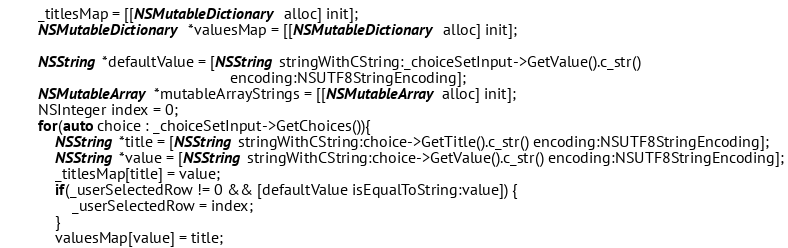<code> <loc_0><loc_0><loc_500><loc_500><_ObjectiveC_>        _titlesMap = [[NSMutableDictionary alloc] init];
        NSMutableDictionary *valuesMap = [[NSMutableDictionary alloc] init];

        NSString *defaultValue = [NSString stringWithCString:_choiceSetInput->GetValue().c_str()
                                                     encoding:NSUTF8StringEncoding];
        NSMutableArray *mutableArrayStrings = [[NSMutableArray alloc] init];
        NSInteger index = 0;
        for(auto choice : _choiceSetInput->GetChoices()){
            NSString *title = [NSString stringWithCString:choice->GetTitle().c_str() encoding:NSUTF8StringEncoding];
            NSString *value = [NSString stringWithCString:choice->GetValue().c_str() encoding:NSUTF8StringEncoding];
            _titlesMap[title] = value;
            if(_userSelectedRow != 0 && [defaultValue isEqualToString:value]) {
                _userSelectedRow = index;
            }
            valuesMap[value] = title;</code> 